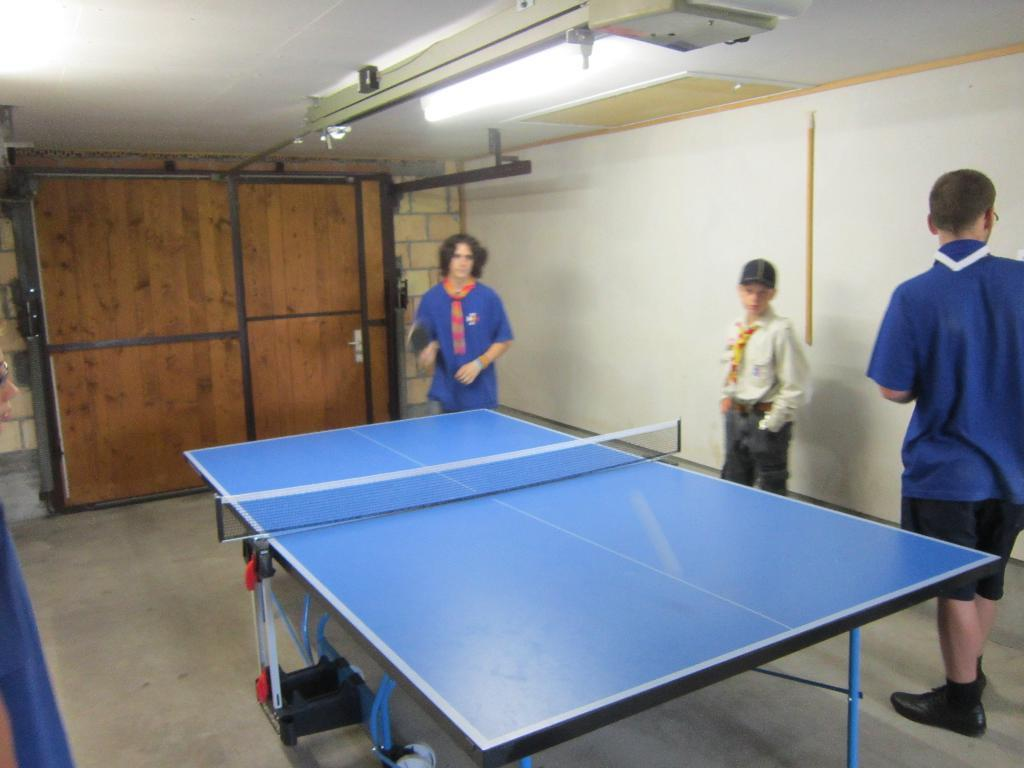How many people are in the image? There are three persons in the image. What are the persons doing in the image? The persons are standing near a table tennis board. What type of door can be seen in the image? There is a wooden door visible in the image. What type of lighting is present in the image? Tube lights are present in the image. How many chairs are there in the image? There is no mention of chairs in the image, so we cannot determine the number of chairs present. 